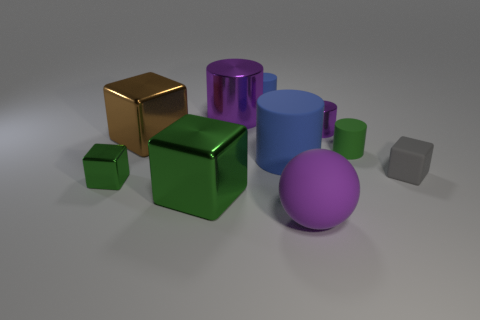Subtract all gray rubber blocks. How many blocks are left? 3 Subtract all green blocks. How many blocks are left? 2 Subtract all cubes. How many objects are left? 6 Subtract 4 cubes. How many cubes are left? 0 Add 5 tiny metal blocks. How many tiny metal blocks are left? 6 Add 3 big green rubber blocks. How many big green rubber blocks exist? 3 Subtract 1 green cubes. How many objects are left? 9 Subtract all gray cylinders. Subtract all brown cubes. How many cylinders are left? 5 Subtract all purple blocks. How many blue cylinders are left? 2 Subtract all tiny green cylinders. Subtract all small green things. How many objects are left? 7 